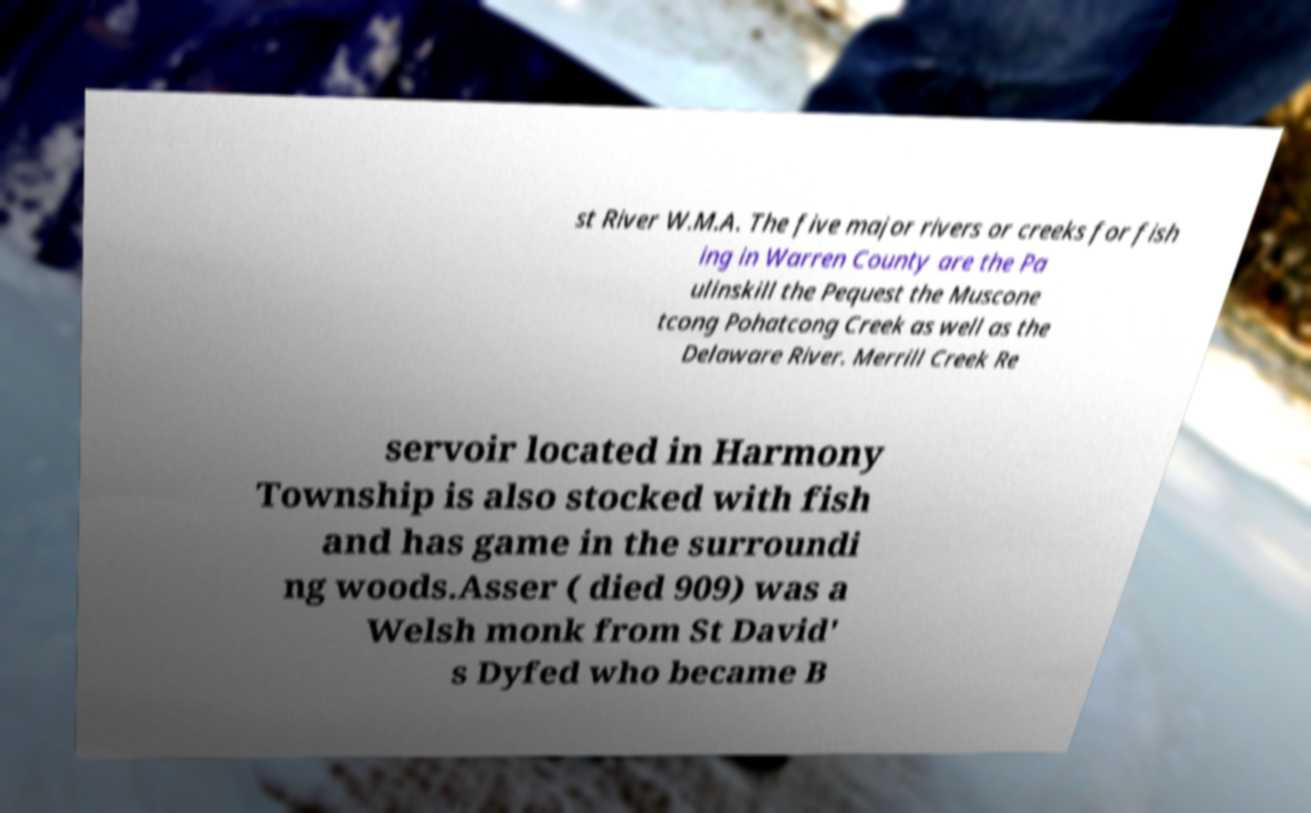What messages or text are displayed in this image? I need them in a readable, typed format. st River W.M.A. The five major rivers or creeks for fish ing in Warren County are the Pa ulinskill the Pequest the Muscone tcong Pohatcong Creek as well as the Delaware River. Merrill Creek Re servoir located in Harmony Township is also stocked with fish and has game in the surroundi ng woods.Asser ( died 909) was a Welsh monk from St David' s Dyfed who became B 